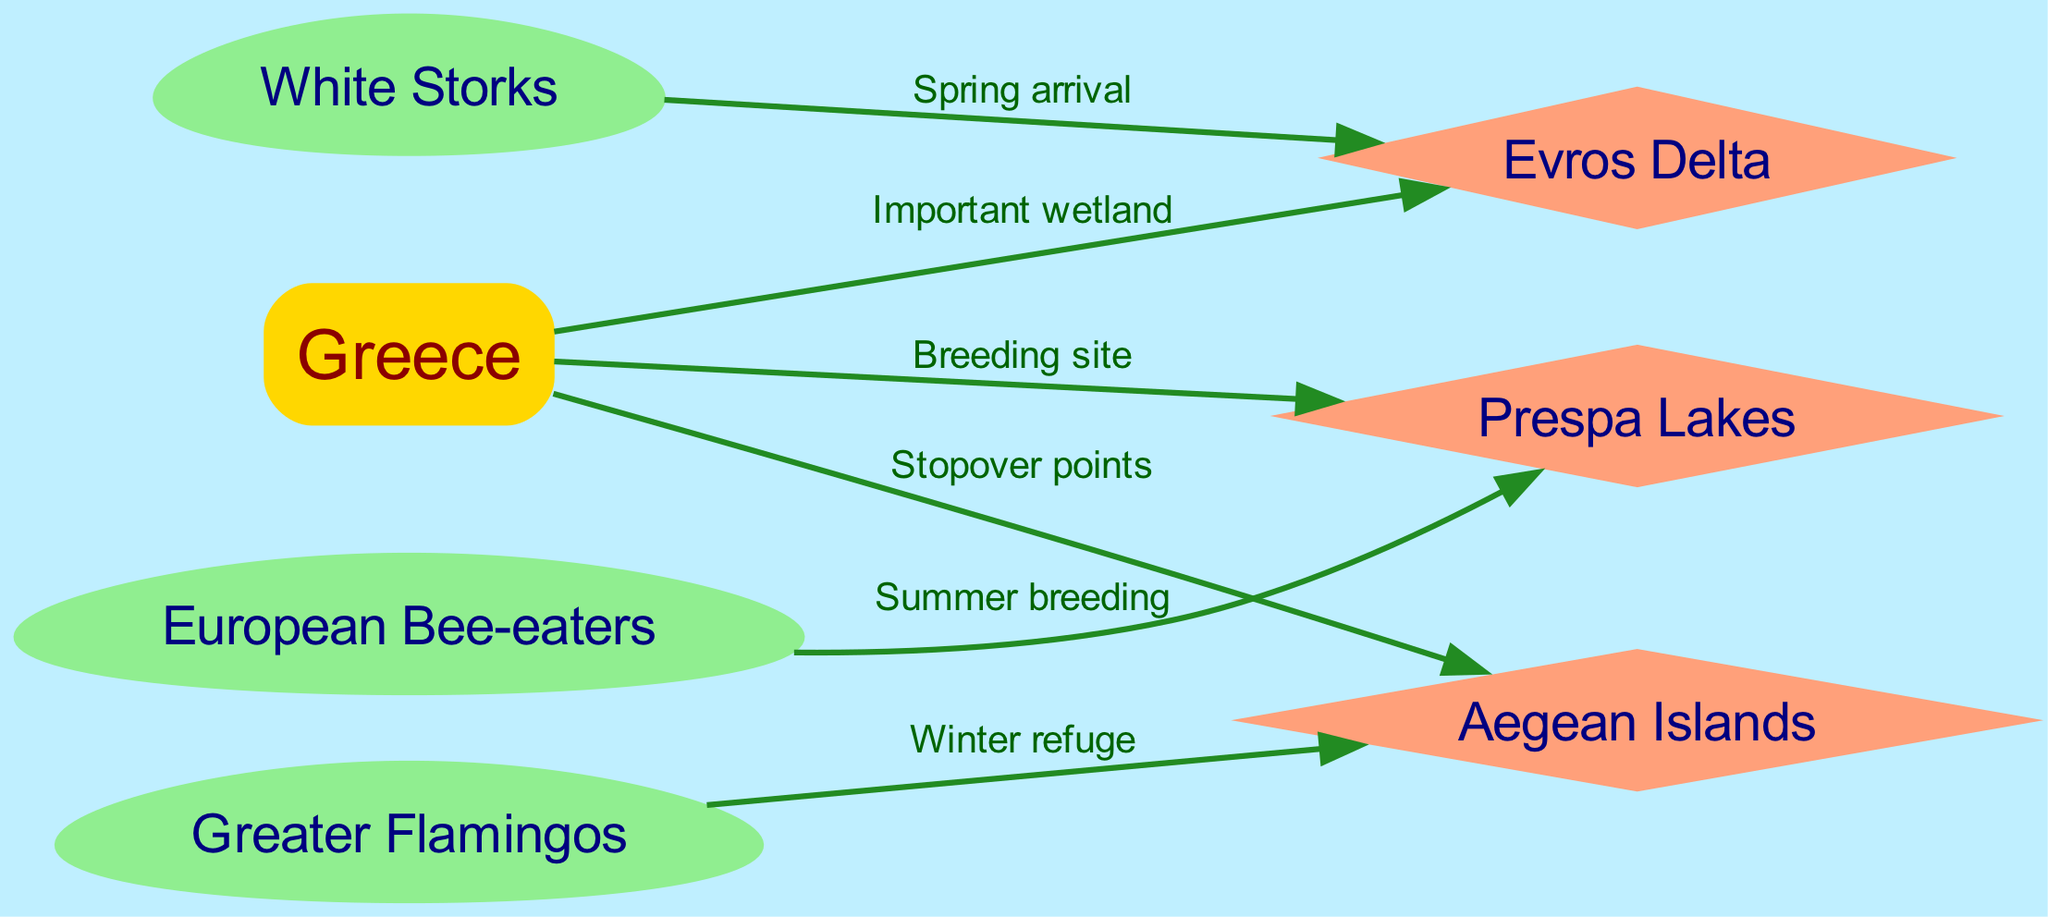What is the primary node representing the country in the diagram? The diagram includes a primary node labeled "Greece," which represents the country around which the migratory patterns are depicted.
Answer: Greece How many nodes are displayed in the diagram? By counting the nodes listed, there are a total of 7 nodes in the diagram, including Greece and various bird species and locations.
Answer: 7 Which bird migrates to the Evros Delta in spring? The diagram indicates that White Storks migrate to the Evros Delta, specifically noted for their spring arrival.
Answer: White Storks What is the relationship between the Greater Flamingos and the Aegean Islands? According to the diagram, the Greater Flamingos have a relationship with the Aegean Islands labeled as "Winter refuge," indicating that they migrate there during winter.
Answer: Winter refuge Which breeding site is linked to the European Bee-eaters? The European Bee-eaters are linked to the Prespa Lakes, where they engage in summer breeding, as noted in the relationships depicted.
Answer: Prespa Lakes How many edges connect the nodes representing the migratory patterns? The diagram shows a total of 6 edges connecting the different nodes, which represent the various migratory relationships.
Answer: 6 Which node is identified as a breeding site in Greece? The diagram specifically identifies the Prespa Lakes as a breeding site within Greece, indicating significance for certain bird species.
Answer: Prespa Lakes What type of relationship is indicated between the White Storks and the Evros Delta? The relationship between the White Storks and the Evros Delta is indicated as "Spring arrival," which highlights the season they migrate there.
Answer: Spring arrival What shape represents Greece in the diagram? Greece is represented by a box shape in the diagram, differentiating it from the other nodes, which are of various shapes.
Answer: Box 